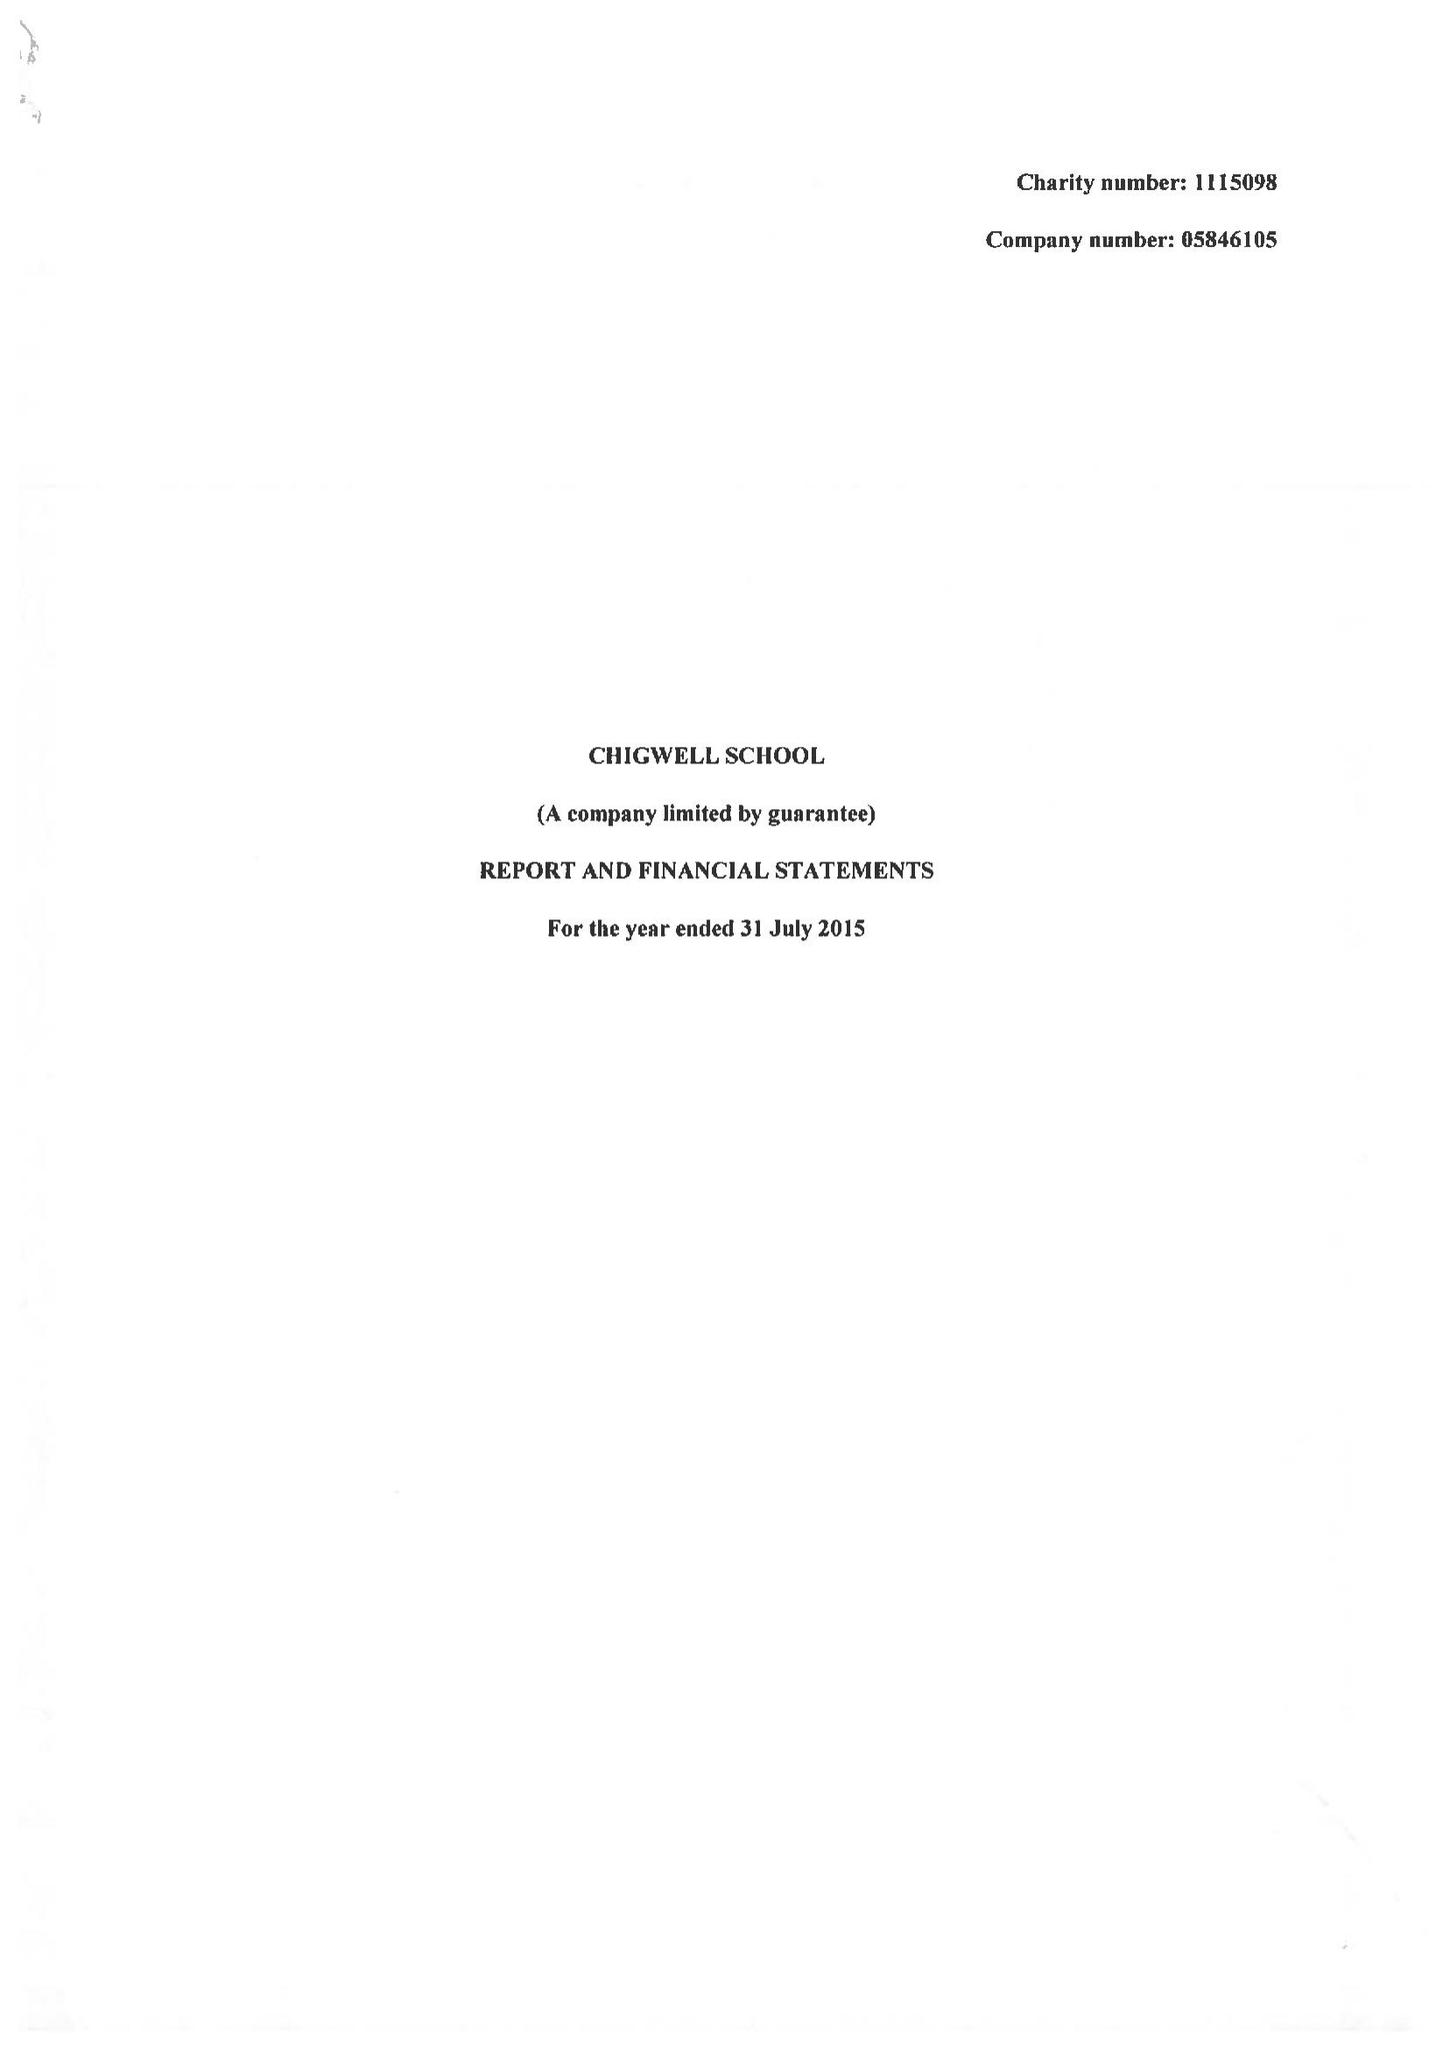What is the value for the address__street_line?
Answer the question using a single word or phrase. HIGH ROAD 